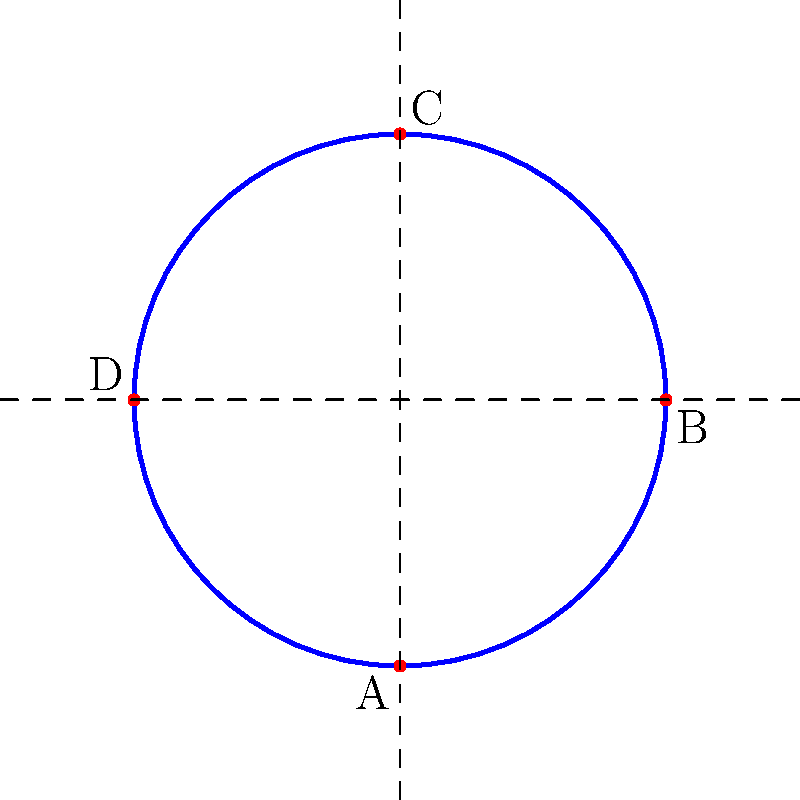In the context of knot theory and its potential analogies to epistemological frameworks in the philosophy of science, consider the simple closed curve shown above. How might this representation relate to the concept of scientific paradigms as described by Thomas Kuhn? Specifically, how could the crossing points (A, B, C, and D) be interpreted in terms of paradigm shifts and the nature of scientific progress? To answer this question, we need to consider the following steps:

1. Understand knot theory basics:
   - A knot in mathematics is a closed curve in three-dimensional space that does not intersect itself.
   - The diagram represents a projection of a three-dimensional knot onto a two-dimensional plane.

2. Recall Kuhn's concept of scientific paradigms:
   - Paradigms are sets of concepts, methods, and standards that define a scientific discipline at a given time.
   - Paradigm shifts occur when anomalies accumulate, leading to a crisis and eventually a new paradigm.

3. Interpret the knot diagram in terms of scientific progress:
   - The continuous curve represents the ongoing process of scientific inquiry.
   - Crossing points (A, B, C, and D) can be seen as potential paradigm shifts or critical junctures in scientific understanding.

4. Analyze the crossing points:
   - Each crossing represents a point where the path of inquiry seems to intersect itself, similar to how new discoveries might challenge or recontextualize previous knowledge.
   - The over/under nature of crossings could symbolize how new paradigms supersede or incorporate aspects of previous ones.

5. Consider the closed nature of the curve:
   - This might represent the cyclical nature of scientific progress, where new paradigms often revisit and reinterpret past ideas in light of new evidence or perspectives.

6. Reflect on the topology:
   - The knot's invariance under continuous deformations could symbolize how fundamental scientific truths persist despite changes in our understanding or approach.

7. Connect to epistemological frameworks:
   - The knot diagram provides a visual metaphor for the interconnected and sometimes self-referential nature of scientific knowledge.
   - It illustrates how progress in science is not always linear but can involve complex interactions between past and present understandings.
Answer: The knot diagram represents scientific progress, with crossing points as paradigm shifts, illustrating the non-linear, interconnected nature of epistemological development in science. 